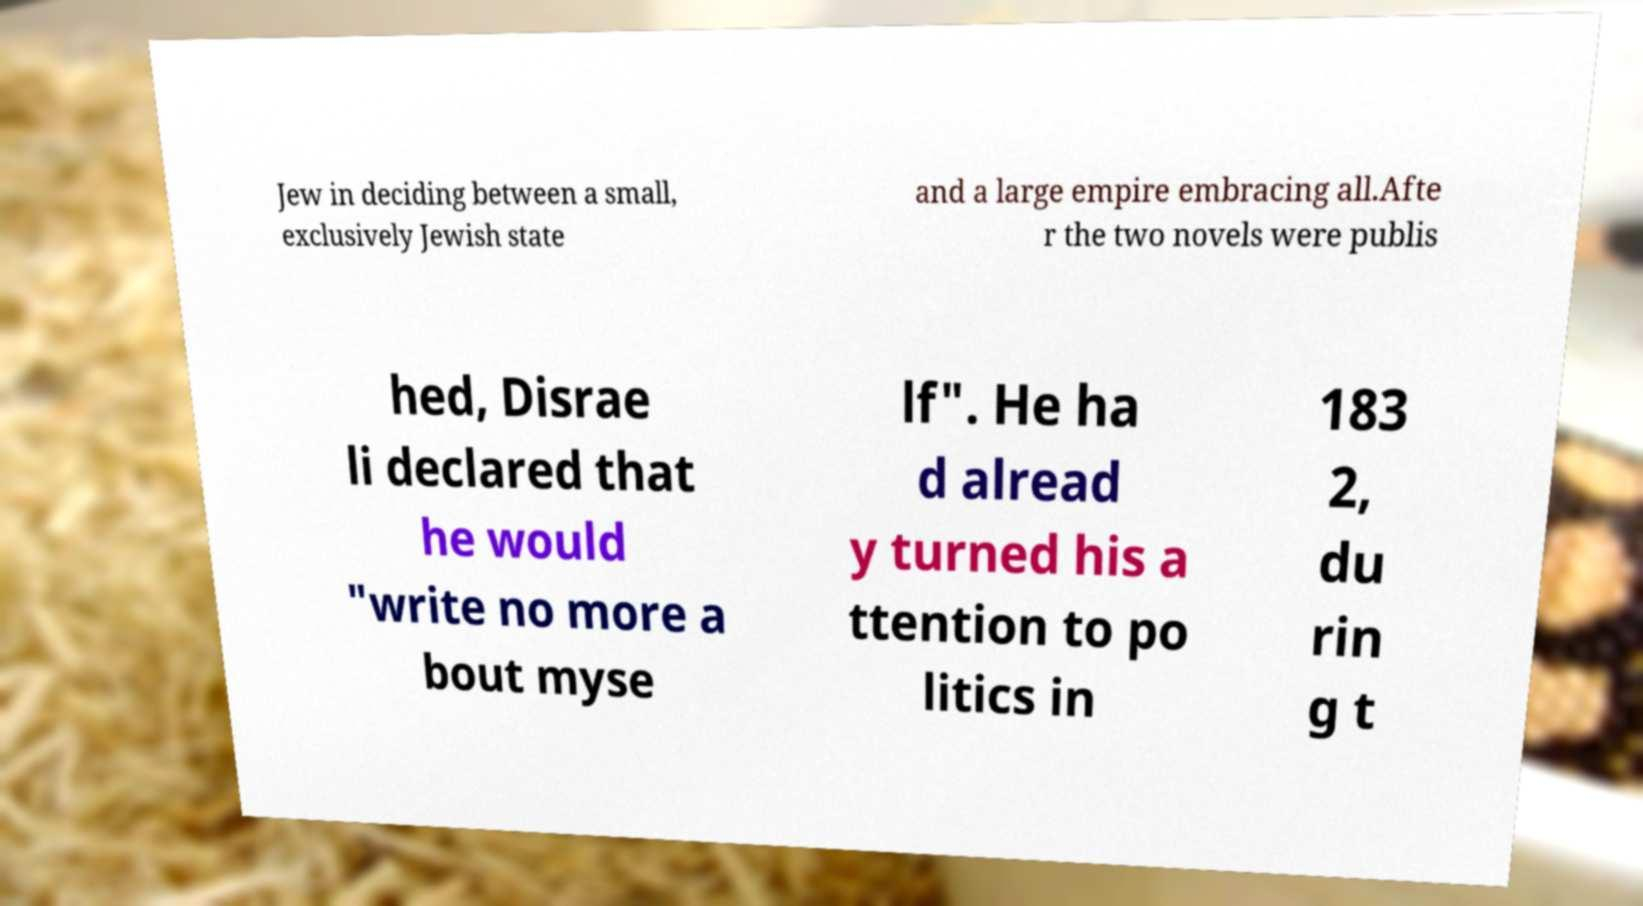Please read and relay the text visible in this image. What does it say? Jew in deciding between a small, exclusively Jewish state and a large empire embracing all.Afte r the two novels were publis hed, Disrae li declared that he would "write no more a bout myse lf". He ha d alread y turned his a ttention to po litics in 183 2, du rin g t 